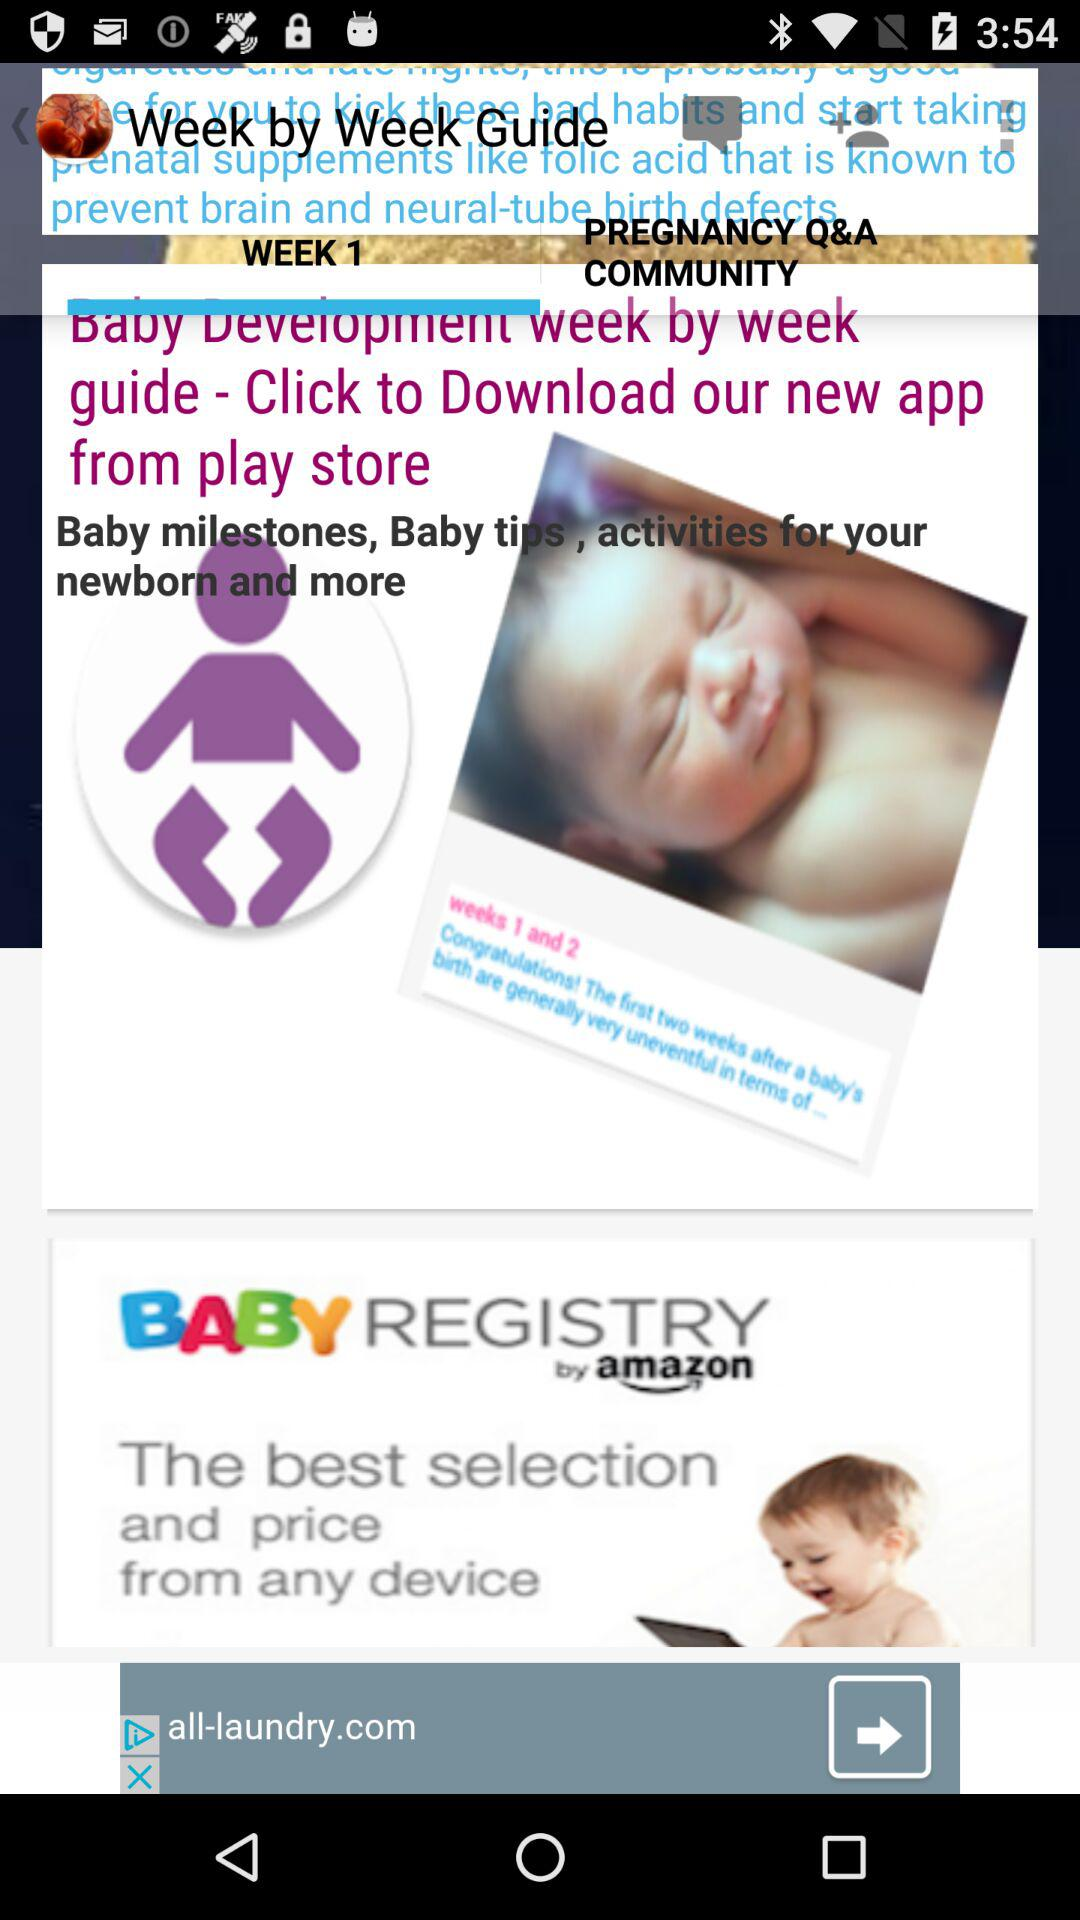Who is the baby named after?
When the provided information is insufficient, respond with <no answer>. <no answer> 